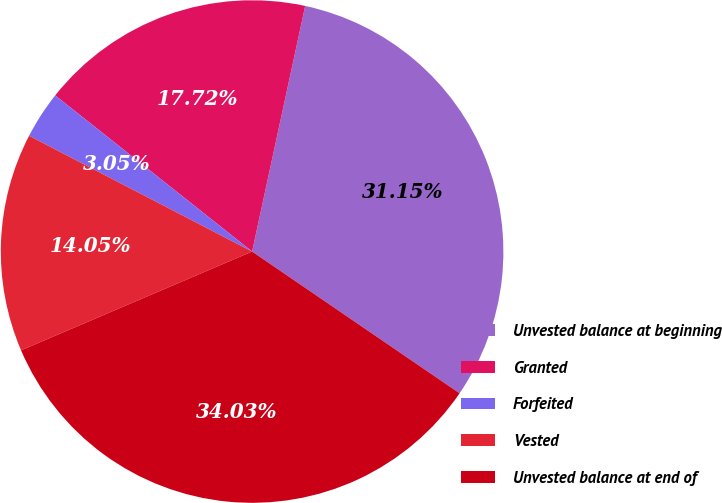Convert chart. <chart><loc_0><loc_0><loc_500><loc_500><pie_chart><fcel>Unvested balance at beginning<fcel>Granted<fcel>Forfeited<fcel>Vested<fcel>Unvested balance at end of<nl><fcel>31.15%<fcel>17.72%<fcel>3.05%<fcel>14.05%<fcel>34.03%<nl></chart> 